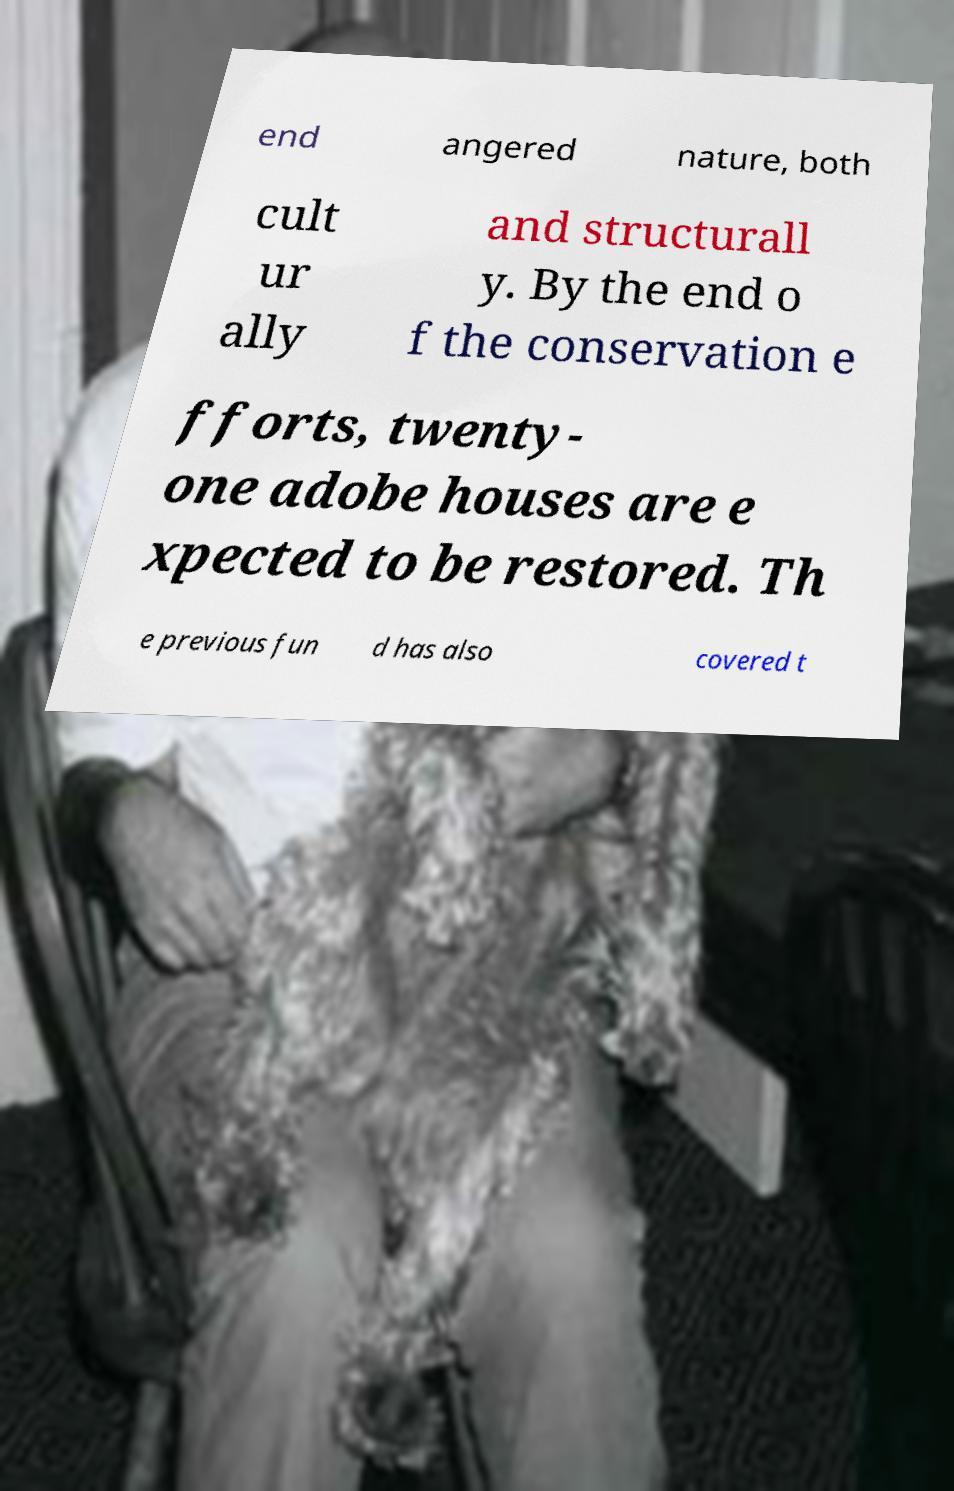Could you extract and type out the text from this image? end angered nature, both cult ur ally and structurall y. By the end o f the conservation e fforts, twenty- one adobe houses are e xpected to be restored. Th e previous fun d has also covered t 